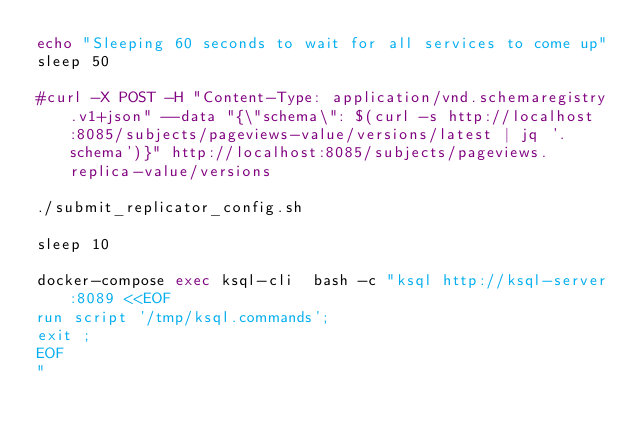Convert code to text. <code><loc_0><loc_0><loc_500><loc_500><_Bash_>echo "Sleeping 60 seconds to wait for all services to come up"
sleep 50

#curl -X POST -H "Content-Type: application/vnd.schemaregistry.v1+json" --data "{\"schema\": $(curl -s http://localhost:8085/subjects/pageviews-value/versions/latest | jq '.schema')}" http://localhost:8085/subjects/pageviews.replica-value/versions 

./submit_replicator_config.sh

sleep 10

docker-compose exec ksql-cli  bash -c "ksql http://ksql-server:8089 <<EOF
run script '/tmp/ksql.commands';
exit ;
EOF
"
</code> 